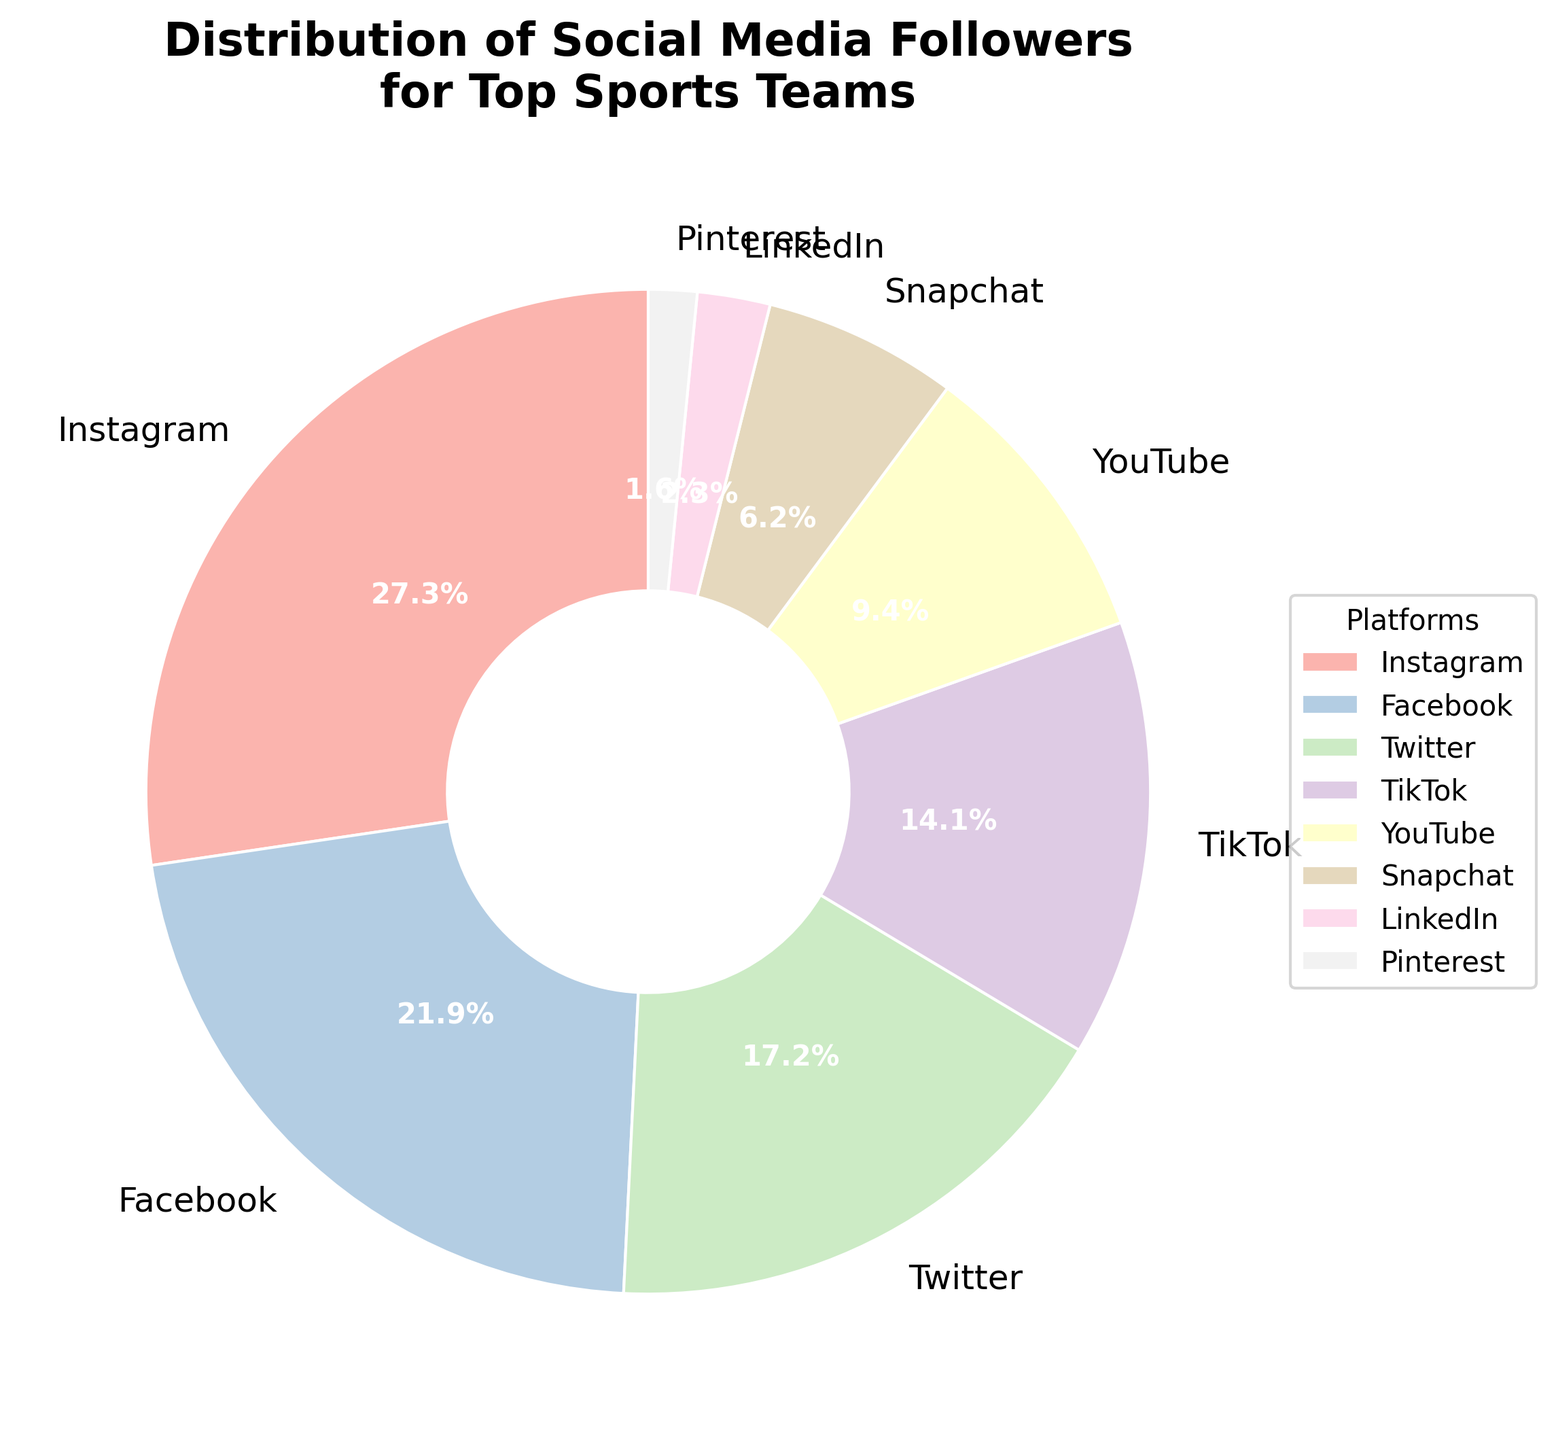Which platform has the highest number of followers? The figure shows the followers for each platform, and Instagram has the largest section of the pie.
Answer: Instagram Which two platforms together have more than 50 million followers? Summing the followers of Instagram (35,000,000) and Facebook (28,000,000) results in 63,000,000, which is more than 50 million.
Answer: Instagram and Facebook What is the percentage of followers on TikTok compared to the total number of followers? TikTok has 18 million followers. To find the percentage, divide TikTok's followers by the total followers (130 million) and multiply by 100. (18/130) * 100 ≈ 13.8%
Answer: 13.8% How many more followers does Instagram have compared to YouTube? Instagram has 35 million followers, and YouTube has 12 million. Subtracting these gives 35,000,000 - 12,000,000 = 23,000,000.
Answer: 23 million Which platform has the smallest number of followers, and what is the percentage of total followers does this represent? Pinterest has the smallest section on the pie with 2 million followers. To find the percentage, (2/130) * 100 ≈ 1.5%.
Answer: Pinterest, 1.5% What is the combined percentage of followers on Twitter and LinkedIn? Twitter has 22 million followers and LinkedIn has 3 million. Combined, it is 25 million. To get the percentage, (25/130) * 100 ≈ 19.2%.
Answer: 19.2% Which has more followers: Snapchat or YouTube? By looking at the segments in the pie chart, YouTube has a larger section than Snapchat.
Answer: YouTube If we were to combine the followers of Instagram, Facebook, and Twitter, what would the combined percentage be out of the total followers? Instagram (35 million) + Facebook (28 million) + Twitter (22 million) = 85 million. To find the percent, (85/130) * 100 ≈ 65.4%.
Answer: 65.4% What is the difference in the percentage of followers between TikTok and Facebook? TikTok has 18 million followers and Facebook has 28 million. First, convert to percentages: TikTok (18/130) * 100 ≈ 13.8% and Facebook (28/130) * 100 ≈ 21.5%. Difference is 21.5% - 13.8% ≈ 7.7%.
Answer: 7.7% 